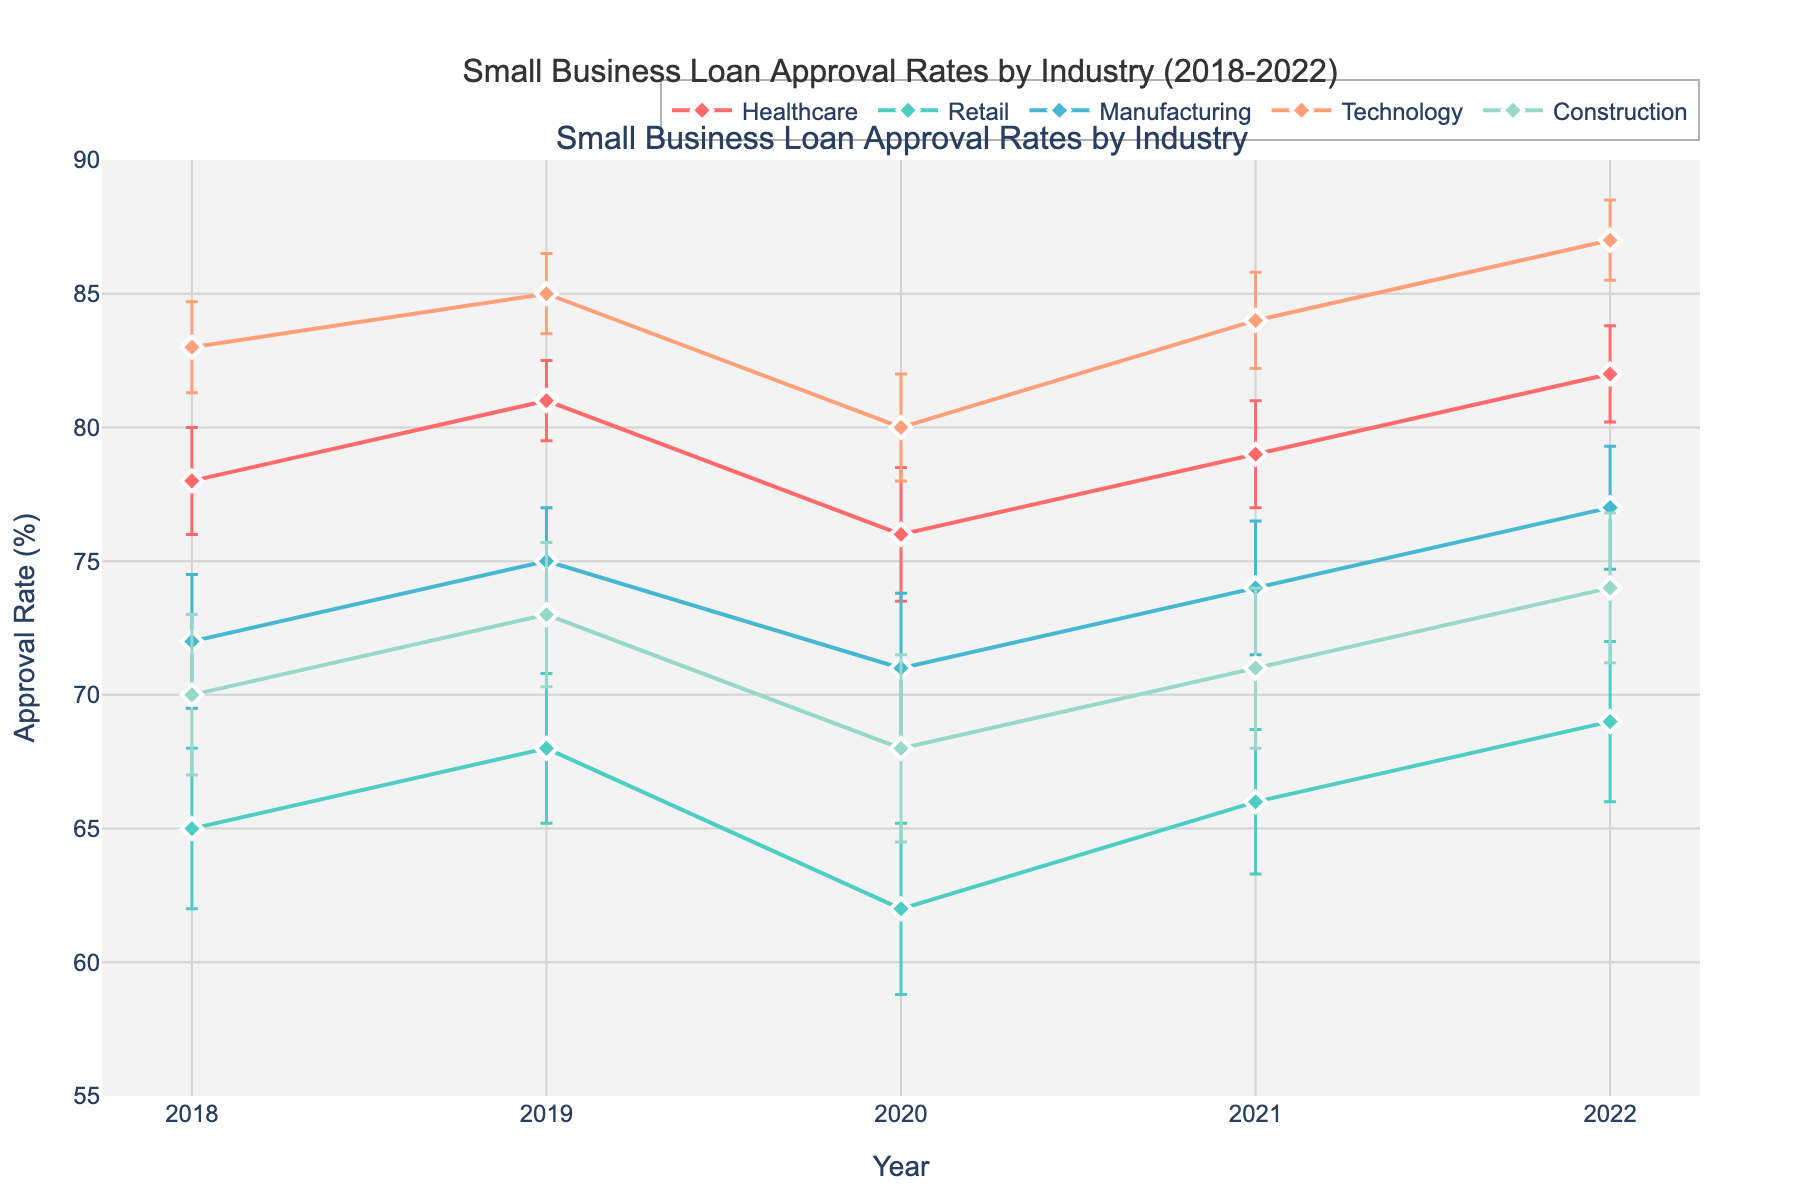Which industry had the highest loan approval rate in 2022? Look at the 2022 data points and see which line reaches the highest value. Technology reaches 87%.
Answer: Technology What was the trend of loan approval rates for the Healthcare industry over the 5-year period? Observe the points for Healthcare from 2018 to 2022 and note their changes. The rate starts at 78%, increases to 81% in 2019, then drops to 76% in 2020, rises again to 79% in 2021, and increased further to 82% in 2022.
Answer: Fluctuating but generally increasing What is the average approval rate for the Retail industry over these 5 years? Add the 5 approval rates for Retail (65+68+62+66+69 = 330) and divide by 5.
Answer: 66% Which industry showed the greatest variability in its loan approval rates? Compare the error bars for each industry across the years. Construction has larger error bars overall.
Answer: Construction How much did the Technology industry's approval rate increase from 2018 to 2022? Subtract the 2018 rate from the 2022 rate for Technology (87 - 83 = 4).
Answer: 4% In which year did the Manufacturing industry see its lowest approval rate? Identify the lowest point in the Manufacturing line, which occurs in 2020 at 71%.
Answer: 2020 Which industry had the least consistent loan approval rates? Identify the industry with the greatest fluctuation in approval rates year-to-year. Retail goes from 65% to 69%, which is the largest difference.
Answer: Retail Which industry shows almost consistent improvement in approval rates over the years? Look for a generally linear upward trend among industries. Technology shows a consistent increase with minimal fluctuations.
Answer: Technology What was the loan approval rate for the Healthcare industry in 2020, and how did it compare to the Technology industry's rate in the same year? Check the 2020 data for Healthcare and Technology. Healthcare is at 76%, and Technology is at 80%. Comparing 76% to 80%, Technology is higher.
Answer: 76%, lower by 4% By how much did the approval rate for Construction change from 2018 to 2022? Subtract the 2018 rate from the 2022 rate for Construction (74 - 70 = 4).
Answer: 4% 